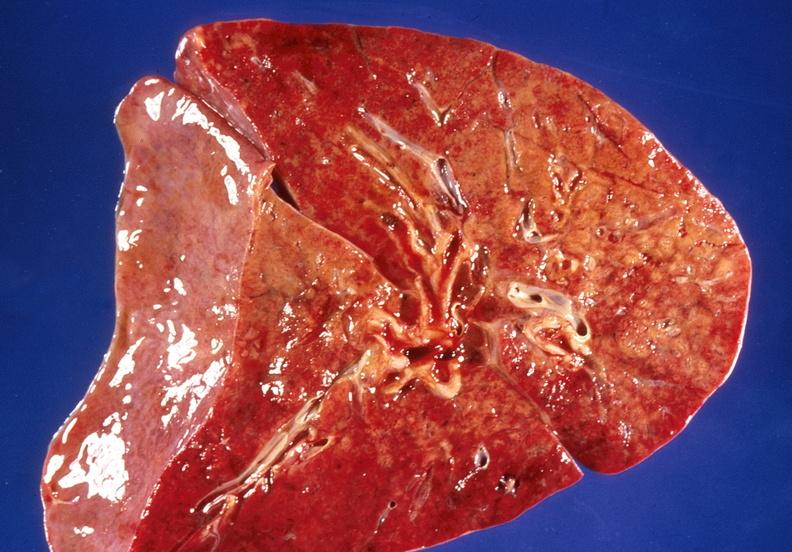does lesion show lung, bronchopneumonia, cystic fibrosis?
Answer the question using a single word or phrase. No 